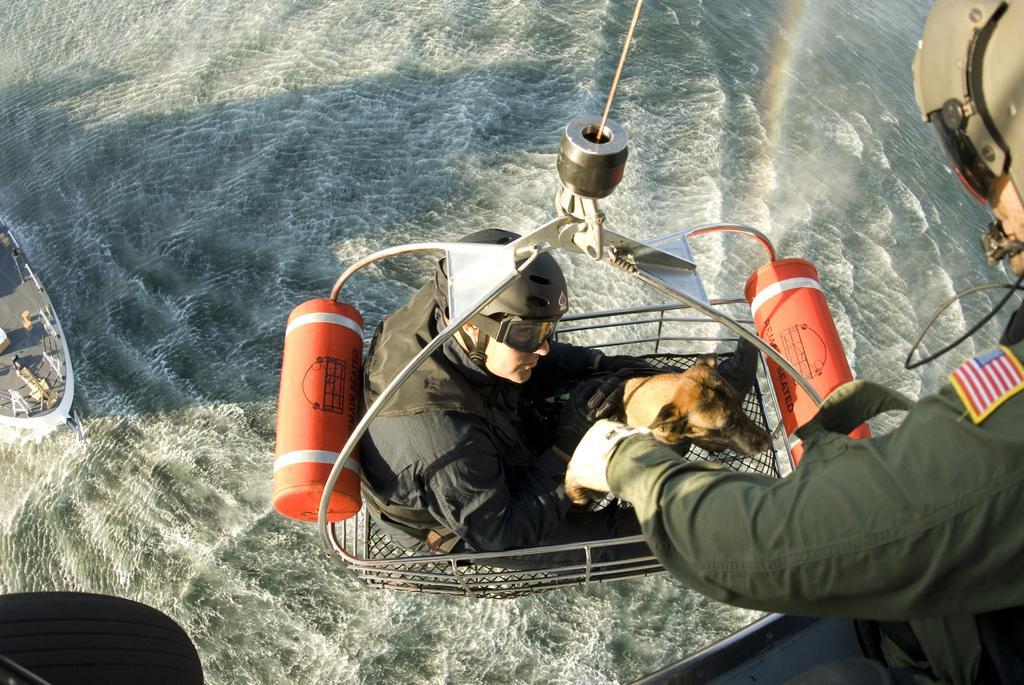Please provide a concise description of this image. In this image there is a trolley , on which there is a person, dog, cylinders attached to it, on the right side there is a person, on the left side there is a ship visible on the sea. 